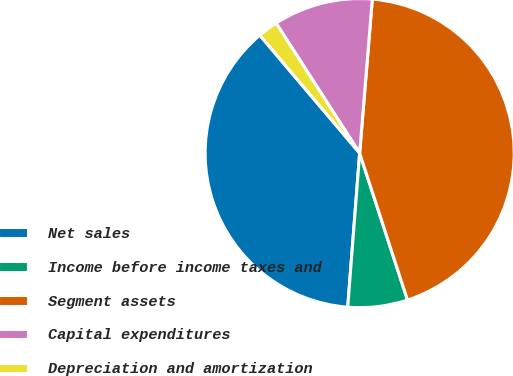Convert chart. <chart><loc_0><loc_0><loc_500><loc_500><pie_chart><fcel>Net sales<fcel>Income before income taxes and<fcel>Segment assets<fcel>Capital expenditures<fcel>Depreciation and amortization<nl><fcel>37.58%<fcel>6.24%<fcel>43.68%<fcel>10.4%<fcel>2.09%<nl></chart> 